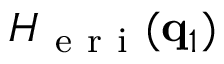<formula> <loc_0><loc_0><loc_500><loc_500>H _ { e r i } ( q _ { 1 } )</formula> 